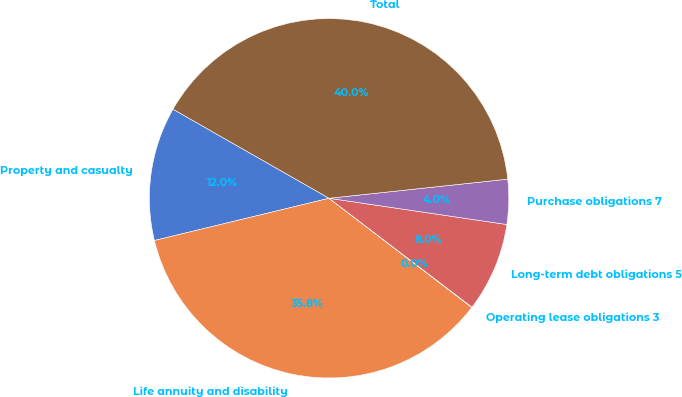Convert chart to OTSL. <chart><loc_0><loc_0><loc_500><loc_500><pie_chart><fcel>Property and casualty<fcel>Life annuity and disability<fcel>Operating lease obligations 3<fcel>Long-term debt obligations 5<fcel>Purchase obligations 7<fcel>Total<nl><fcel>12.03%<fcel>35.83%<fcel>0.03%<fcel>8.03%<fcel>4.03%<fcel>40.05%<nl></chart> 